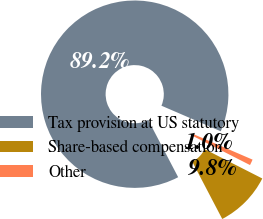<chart> <loc_0><loc_0><loc_500><loc_500><pie_chart><fcel>Tax provision at US statutory<fcel>Share-based compensation<fcel>Other<nl><fcel>89.15%<fcel>9.83%<fcel>1.02%<nl></chart> 